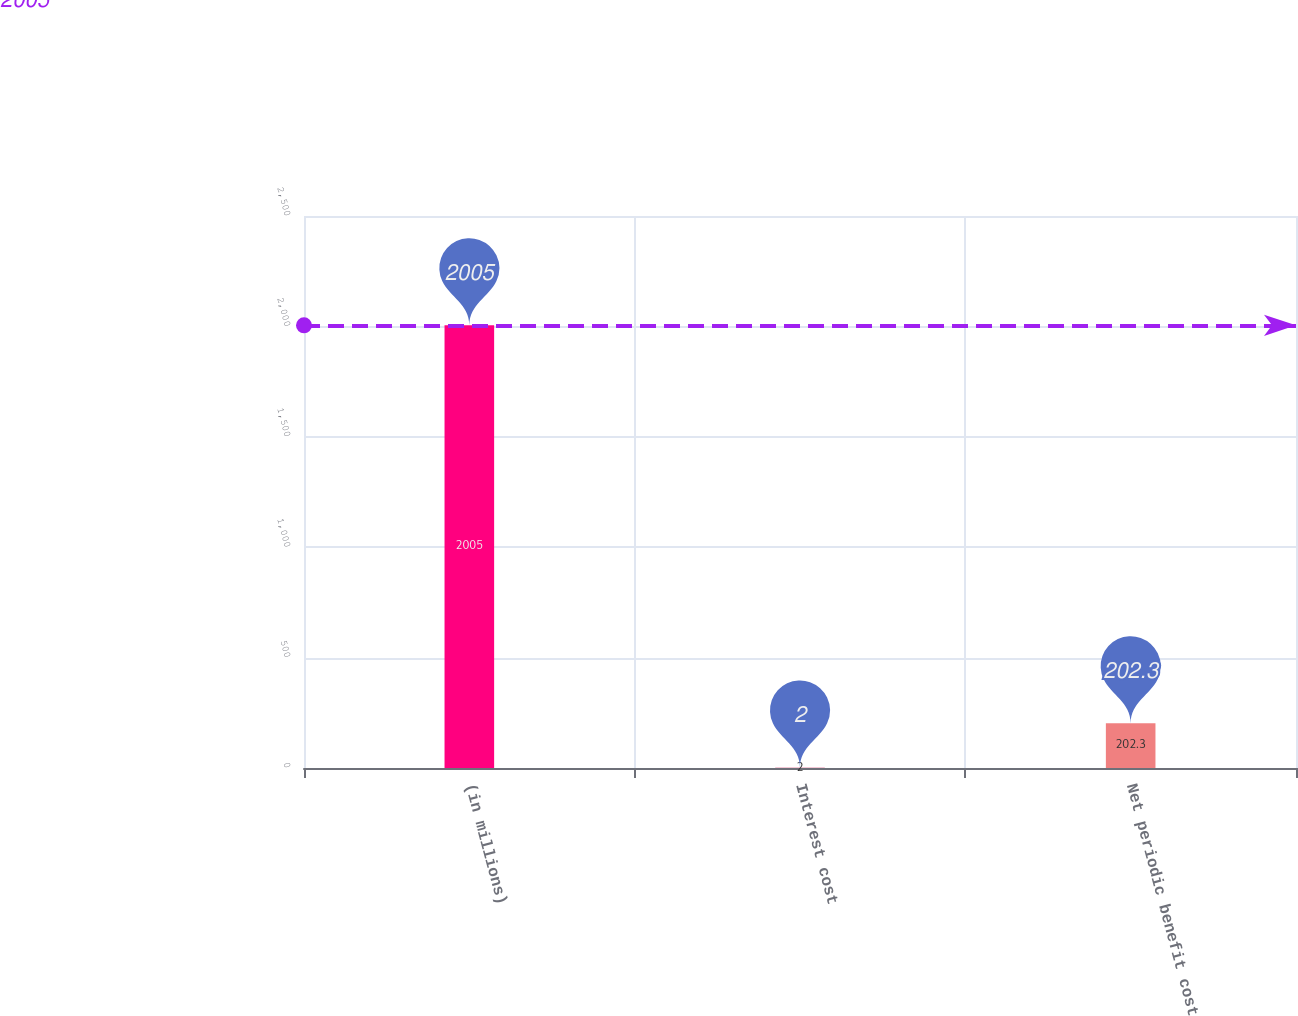Convert chart to OTSL. <chart><loc_0><loc_0><loc_500><loc_500><bar_chart><fcel>(in millions)<fcel>Interest cost<fcel>Net periodic benefit cost<nl><fcel>2005<fcel>2<fcel>202.3<nl></chart> 